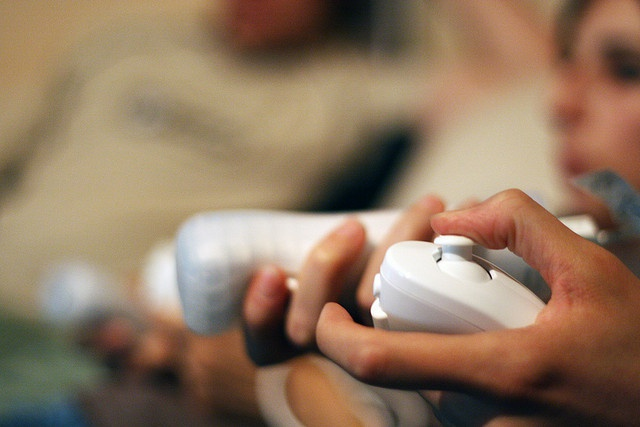Describe the objects in this image and their specific colors. I can see people in tan and gray tones, people in tan, brown, black, and maroon tones, people in tan, brown, and maroon tones, remote in tan, lightgray, darkgray, and gray tones, and remote in tan, lightgray, and darkgray tones in this image. 